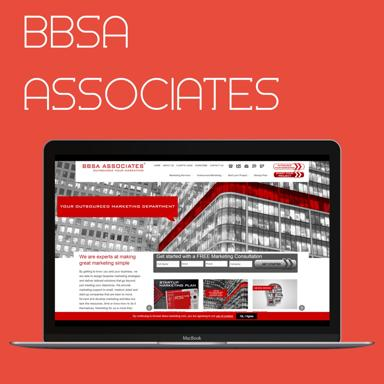Can you describe the design aesthetic of the website shown on the laptop? The website on the laptop showcases a modern and professional design aesthetic. It features a clean layout with red and white color scheme, which gives it a bold and energetic feel. The graphics are sharp with geometric patterns that add to the contemporary look. 